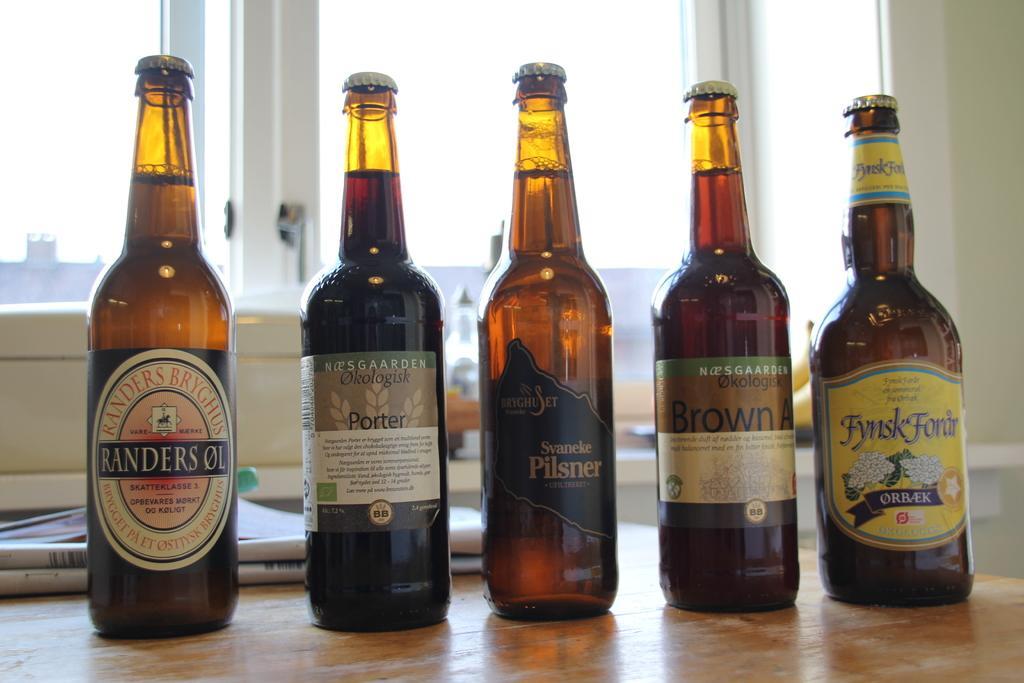Describe this image in one or two sentences. We can see bottle and paper on the table. On the background we can see glass window,wall. 